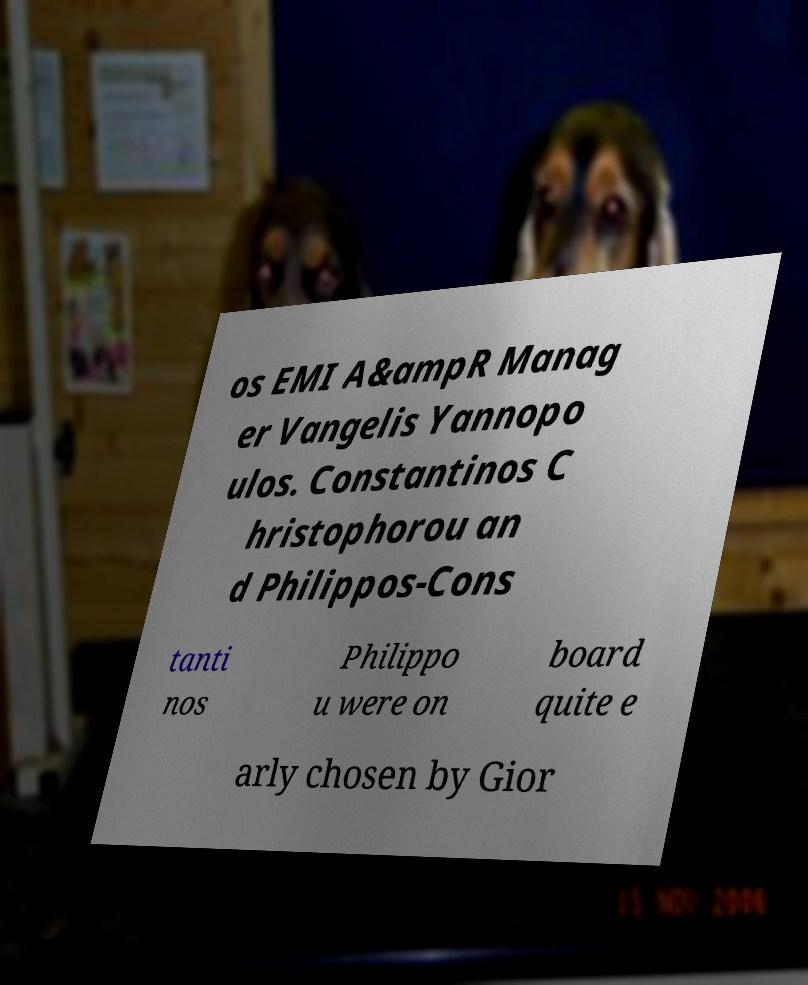Please identify and transcribe the text found in this image. os EMI A&ampR Manag er Vangelis Yannopo ulos. Constantinos C hristophorou an d Philippos-Cons tanti nos Philippo u were on board quite e arly chosen by Gior 